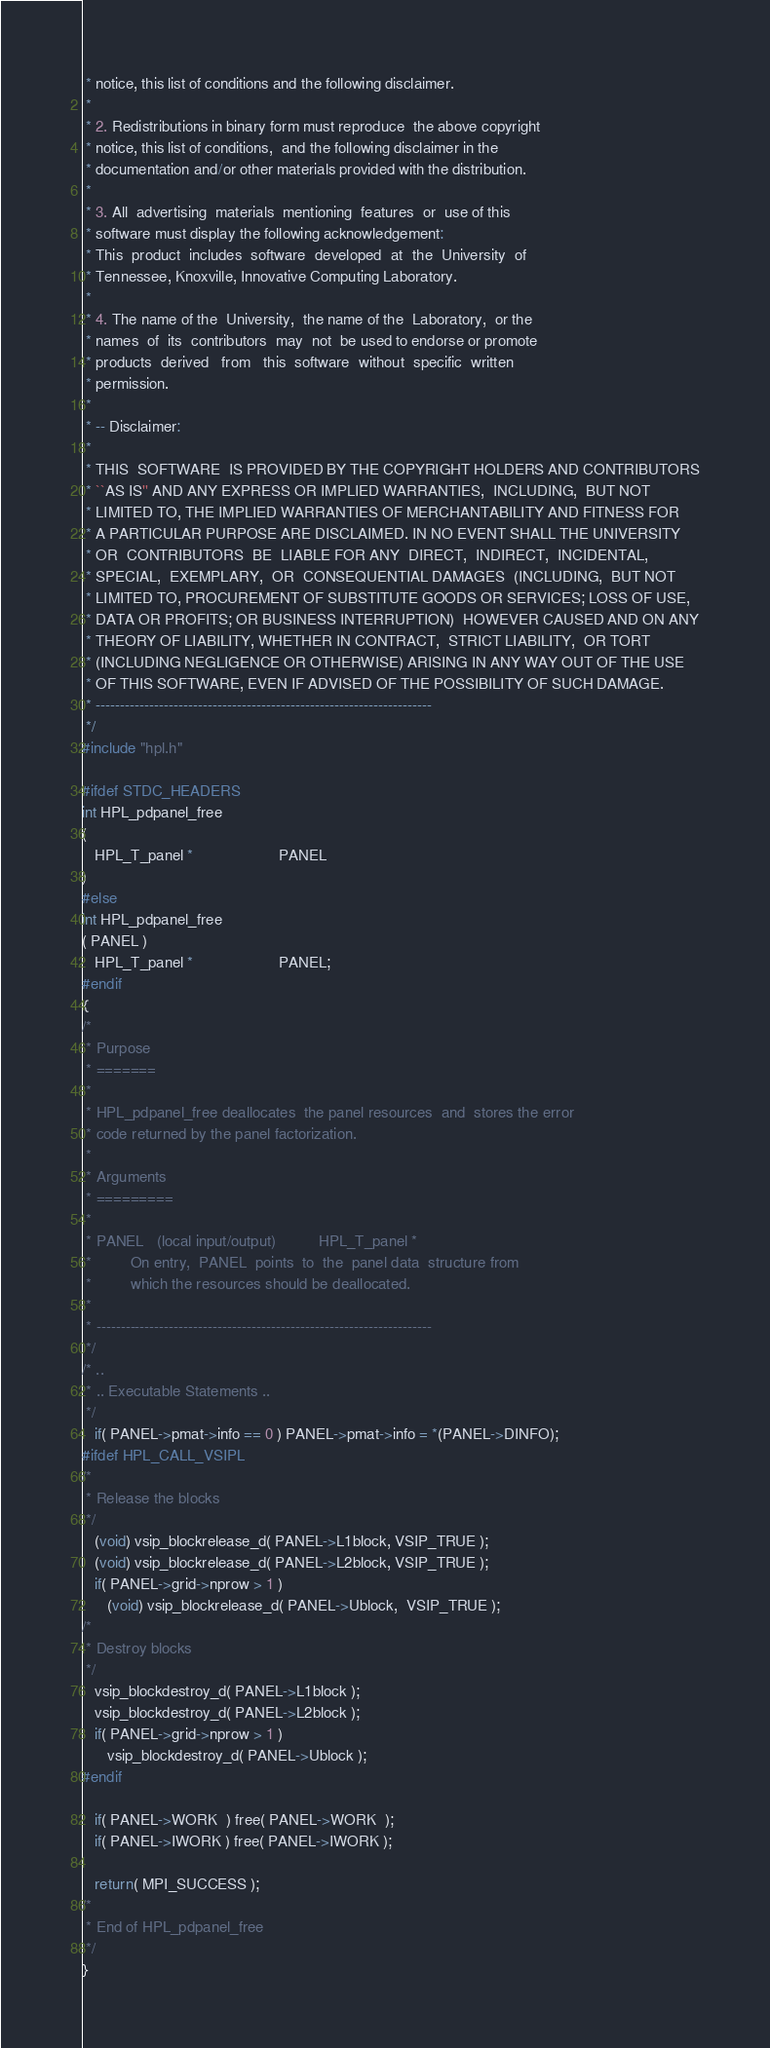Convert code to text. <code><loc_0><loc_0><loc_500><loc_500><_C_> * notice, this list of conditions and the following disclaimer.        
 *                                                                      
 * 2. Redistributions in binary form must reproduce  the above copyright
 * notice, this list of conditions,  and the following disclaimer in the
 * documentation and/or other materials provided with the distribution. 
 *                                                                      
 * 3. All  advertising  materials  mentioning  features  or  use of this
 * software must display the following acknowledgement:                 
 * This  product  includes  software  developed  at  the  University  of
 * Tennessee, Knoxville, Innovative Computing Laboratory.             
 *                                                                      
 * 4. The name of the  University,  the name of the  Laboratory,  or the
 * names  of  its  contributors  may  not  be used to endorse or promote
 * products  derived   from   this  software  without  specific  written
 * permission.                                                          
 *                                                                      
 * -- Disclaimer:                                                       
 *                                                                      
 * THIS  SOFTWARE  IS PROVIDED BY THE COPYRIGHT HOLDERS AND CONTRIBUTORS
 * ``AS IS'' AND ANY EXPRESS OR IMPLIED WARRANTIES,  INCLUDING,  BUT NOT
 * LIMITED TO, THE IMPLIED WARRANTIES OF MERCHANTABILITY AND FITNESS FOR
 * A PARTICULAR PURPOSE ARE DISCLAIMED. IN NO EVENT SHALL THE UNIVERSITY
 * OR  CONTRIBUTORS  BE  LIABLE FOR ANY  DIRECT,  INDIRECT,  INCIDENTAL,
 * SPECIAL,  EXEMPLARY,  OR  CONSEQUENTIAL DAMAGES  (INCLUDING,  BUT NOT
 * LIMITED TO, PROCUREMENT OF SUBSTITUTE GOODS OR SERVICES; LOSS OF USE,
 * DATA OR PROFITS; OR BUSINESS INTERRUPTION)  HOWEVER CAUSED AND ON ANY
 * THEORY OF LIABILITY, WHETHER IN CONTRACT,  STRICT LIABILITY,  OR TORT
 * (INCLUDING NEGLIGENCE OR OTHERWISE) ARISING IN ANY WAY OUT OF THE USE
 * OF THIS SOFTWARE, EVEN IF ADVISED OF THE POSSIBILITY OF SUCH DAMAGE. 
 * ---------------------------------------------------------------------
 */ 
#include "hpl.h"

#ifdef STDC_HEADERS
int HPL_pdpanel_free
(
   HPL_T_panel *                    PANEL
)
#else
int HPL_pdpanel_free
( PANEL )
   HPL_T_panel *                    PANEL;
#endif
{
/* 
 * Purpose
 * =======
 *
 * HPL_pdpanel_free deallocates  the panel resources  and  stores the error
 * code returned by the panel factorization.
 *
 * Arguments
 * =========
 *
 * PANEL   (local input/output)          HPL_T_panel *
 *         On entry,  PANEL  points  to  the  panel data  structure from
 *         which the resources should be deallocated.
 *
 * ---------------------------------------------------------------------
 */ 
/* ..
 * .. Executable Statements ..
 */
   if( PANEL->pmat->info == 0 ) PANEL->pmat->info = *(PANEL->DINFO);
#ifdef HPL_CALL_VSIPL
/*
 * Release the blocks
 */
   (void) vsip_blockrelease_d( PANEL->L1block, VSIP_TRUE );
   (void) vsip_blockrelease_d( PANEL->L2block, VSIP_TRUE );
   if( PANEL->grid->nprow > 1 )
      (void) vsip_blockrelease_d( PANEL->Ublock,  VSIP_TRUE );
/*
 * Destroy blocks
 */
   vsip_blockdestroy_d( PANEL->L1block );
   vsip_blockdestroy_d( PANEL->L2block );
   if( PANEL->grid->nprow > 1 )
      vsip_blockdestroy_d( PANEL->Ublock );
#endif

   if( PANEL->WORK  ) free( PANEL->WORK  );
   if( PANEL->IWORK ) free( PANEL->IWORK );

   return( MPI_SUCCESS );
/*
 * End of HPL_pdpanel_free
 */
}
</code> 